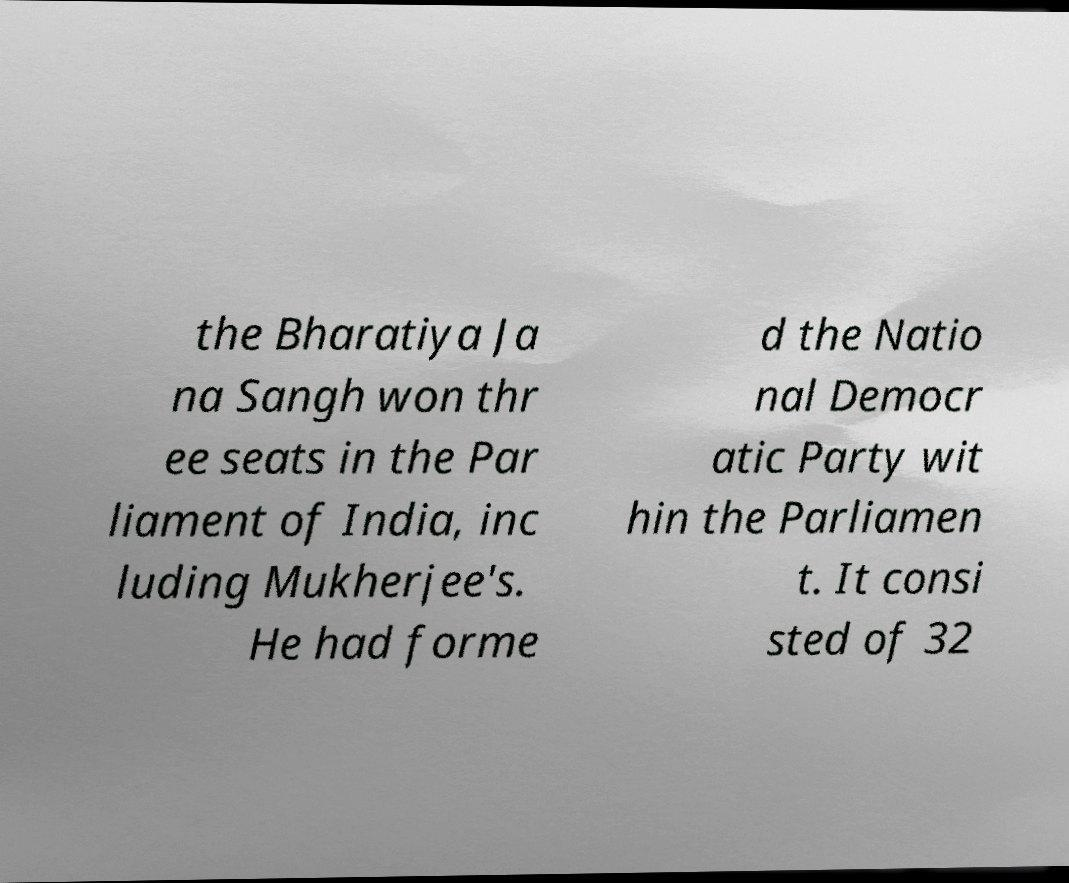What messages or text are displayed in this image? I need them in a readable, typed format. the Bharatiya Ja na Sangh won thr ee seats in the Par liament of India, inc luding Mukherjee's. He had forme d the Natio nal Democr atic Party wit hin the Parliamen t. It consi sted of 32 